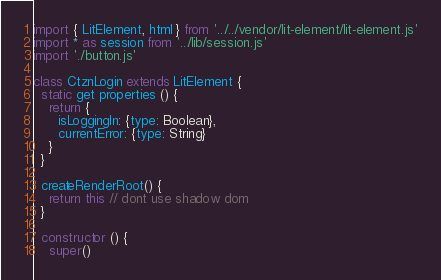Convert code to text. <code><loc_0><loc_0><loc_500><loc_500><_JavaScript_>import { LitElement, html } from '../../vendor/lit-element/lit-element.js'
import * as session from '../lib/session.js'
import './button.js'

class CtznLogin extends LitElement {
  static get properties () {
    return {
      isLoggingIn: {type: Boolean},
      currentError: {type: String}
    }
  }

  createRenderRoot() {
    return this // dont use shadow dom
  }

  constructor () {
    super()</code> 